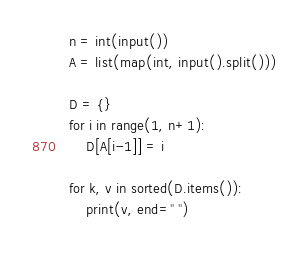Convert code to text. <code><loc_0><loc_0><loc_500><loc_500><_Python_>n = int(input())
A = list(map(int, input().split()))

D = {}
for i in range(1, n+1):
    D[A[i-1]] = i

for k, v in sorted(D.items()):
    print(v, end=" ")</code> 